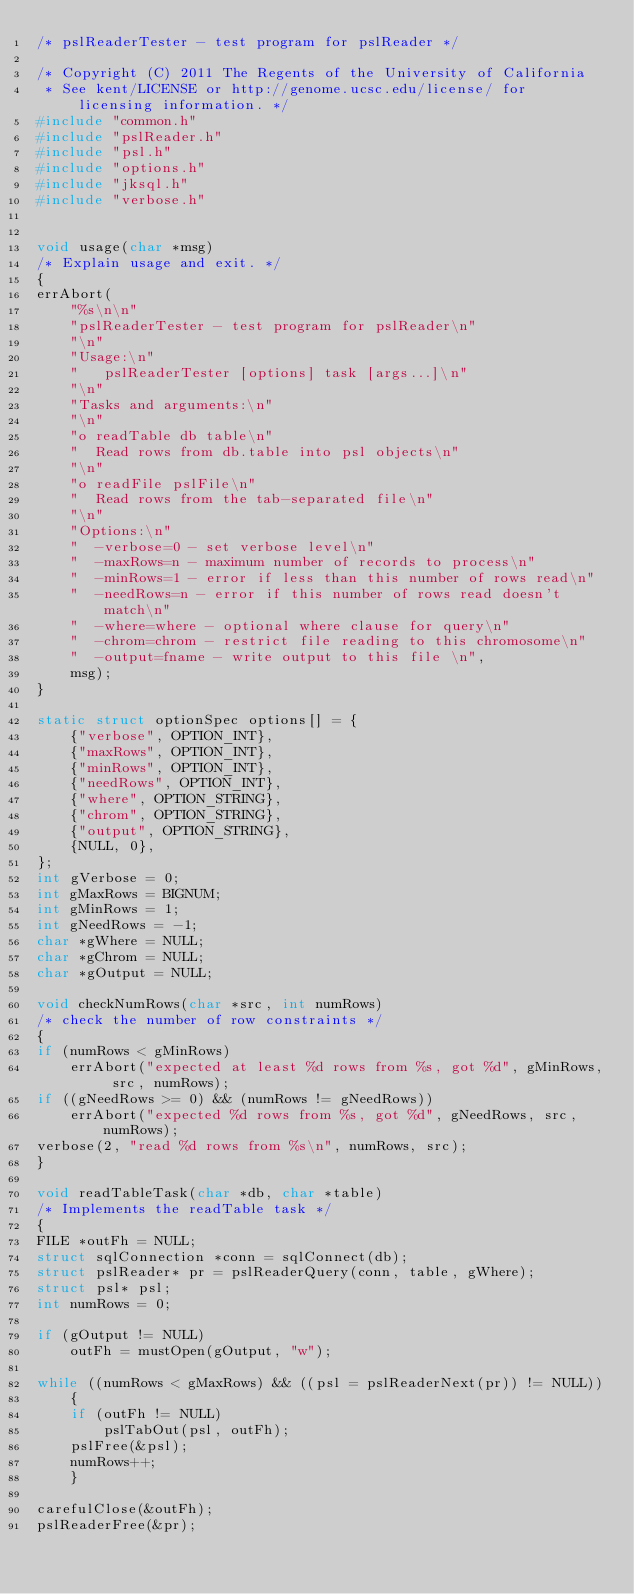Convert code to text. <code><loc_0><loc_0><loc_500><loc_500><_C_>/* pslReaderTester - test program for pslReader */

/* Copyright (C) 2011 The Regents of the University of California 
 * See kent/LICENSE or http://genome.ucsc.edu/license/ for licensing information. */
#include "common.h"
#include "pslReader.h"
#include "psl.h"
#include "options.h"
#include "jksql.h"
#include "verbose.h"


void usage(char *msg)
/* Explain usage and exit. */
{
errAbort(
    "%s\n\n"
    "pslReaderTester - test program for pslReader\n"
    "\n"
    "Usage:\n"
    "   pslReaderTester [options] task [args...]\n"
    "\n"
    "Tasks and arguments:\n"
    "\n"
    "o readTable db table\n"
    "  Read rows from db.table into psl objects\n"
    "\n"
    "o readFile pslFile\n"
    "  Read rows from the tab-separated file\n"
    "\n"
    "Options:\n"
    "  -verbose=0 - set verbose level\n"
    "  -maxRows=n - maximum number of records to process\n"
    "  -minRows=1 - error if less than this number of rows read\n"
    "  -needRows=n - error if this number of rows read doesn't match\n"
    "  -where=where - optional where clause for query\n"
    "  -chrom=chrom - restrict file reading to this chromosome\n"
    "  -output=fname - write output to this file \n",
    msg);
}

static struct optionSpec options[] = {
    {"verbose", OPTION_INT},
    {"maxRows", OPTION_INT},
    {"minRows", OPTION_INT},
    {"needRows", OPTION_INT},
    {"where", OPTION_STRING},
    {"chrom", OPTION_STRING},
    {"output", OPTION_STRING},
    {NULL, 0},
};
int gVerbose = 0;
int gMaxRows = BIGNUM;
int gMinRows = 1;
int gNeedRows = -1;
char *gWhere = NULL;
char *gChrom = NULL;
char *gOutput = NULL;

void checkNumRows(char *src, int numRows)
/* check the number of row constraints */
{
if (numRows < gMinRows)
    errAbort("expected at least %d rows from %s, got %d", gMinRows, src, numRows);
if ((gNeedRows >= 0) && (numRows != gNeedRows))
    errAbort("expected %d rows from %s, got %d", gNeedRows, src, numRows);
verbose(2, "read %d rows from %s\n", numRows, src);
}

void readTableTask(char *db, char *table)
/* Implements the readTable task */
{
FILE *outFh = NULL;
struct sqlConnection *conn = sqlConnect(db);
struct pslReader* pr = pslReaderQuery(conn, table, gWhere);
struct psl* psl;
int numRows = 0;

if (gOutput != NULL)
    outFh = mustOpen(gOutput, "w");

while ((numRows < gMaxRows) && ((psl = pslReaderNext(pr)) != NULL))
    {
    if (outFh != NULL)
        pslTabOut(psl, outFh);
    pslFree(&psl);
    numRows++;
    }

carefulClose(&outFh);
pslReaderFree(&pr);
</code> 